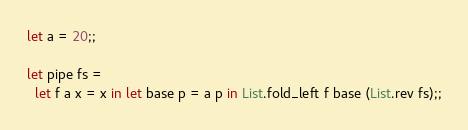Convert code to text. <code><loc_0><loc_0><loc_500><loc_500><_OCaml_>
let a = 20;;

let pipe fs =
  let f a x = x in let base p = a p in List.fold_left f base (List.rev fs);;
</code> 